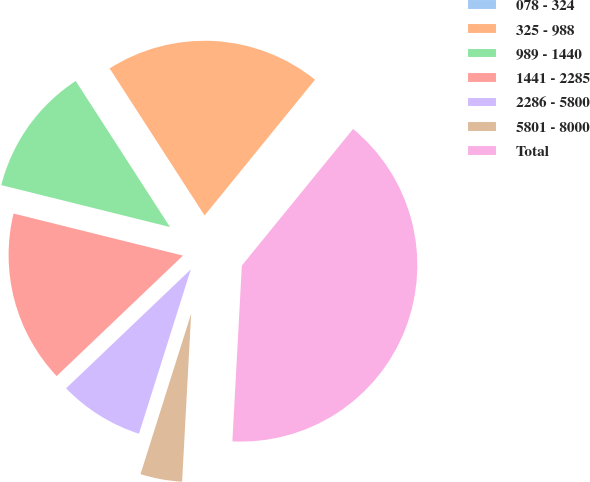Convert chart. <chart><loc_0><loc_0><loc_500><loc_500><pie_chart><fcel>078 - 324<fcel>325 - 988<fcel>989 - 1440<fcel>1441 - 2285<fcel>2286 - 5800<fcel>5801 - 8000<fcel>Total<nl><fcel>0.01%<fcel>19.99%<fcel>12.0%<fcel>16.0%<fcel>8.01%<fcel>4.01%<fcel>39.98%<nl></chart> 